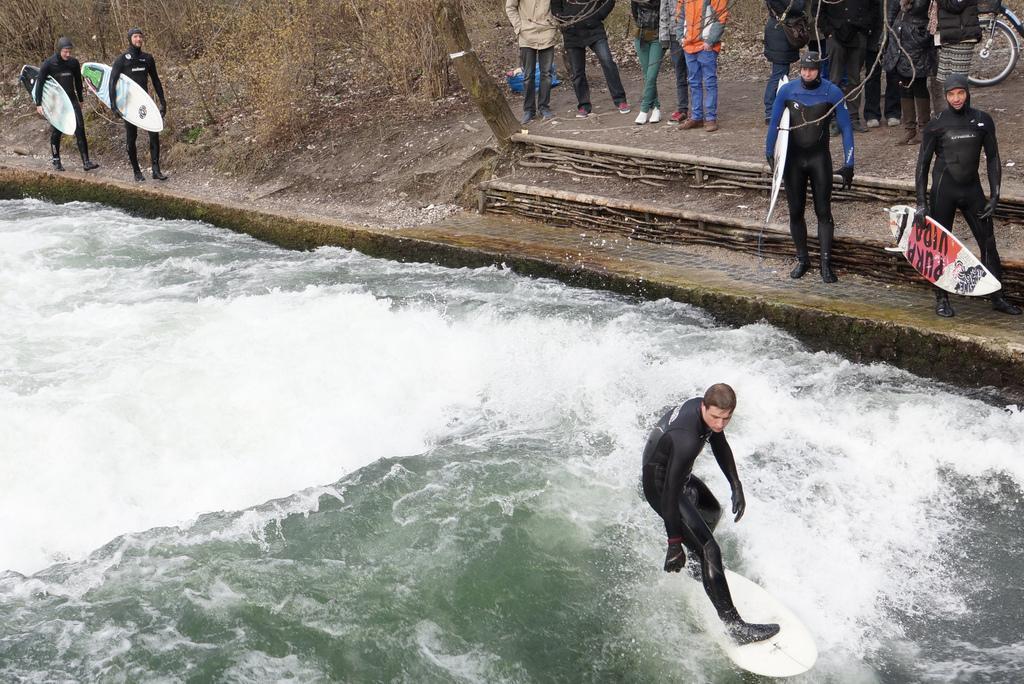How many people are surfing in the water?
Give a very brief answer. 1. How many people are carrying surfboards?
Give a very brief answer. 4. 